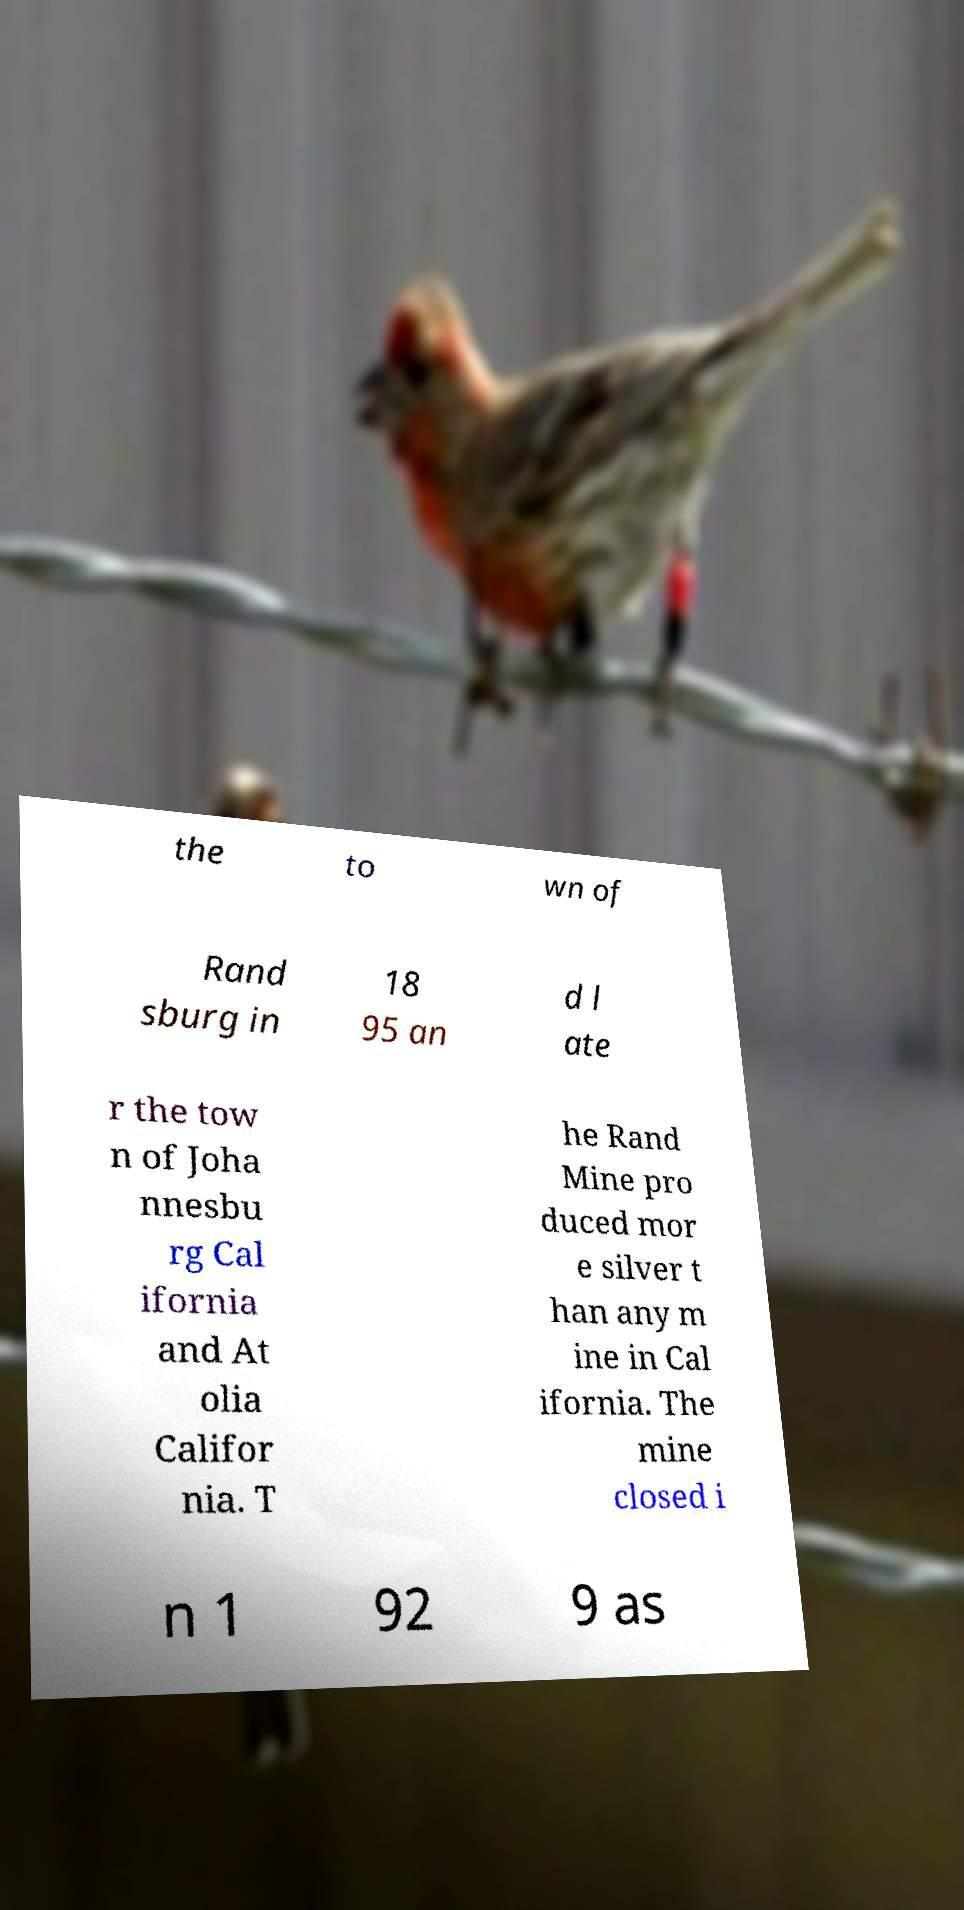I need the written content from this picture converted into text. Can you do that? the to wn of Rand sburg in 18 95 an d l ate r the tow n of Joha nnesbu rg Cal ifornia and At olia Califor nia. T he Rand Mine pro duced mor e silver t han any m ine in Cal ifornia. The mine closed i n 1 92 9 as 